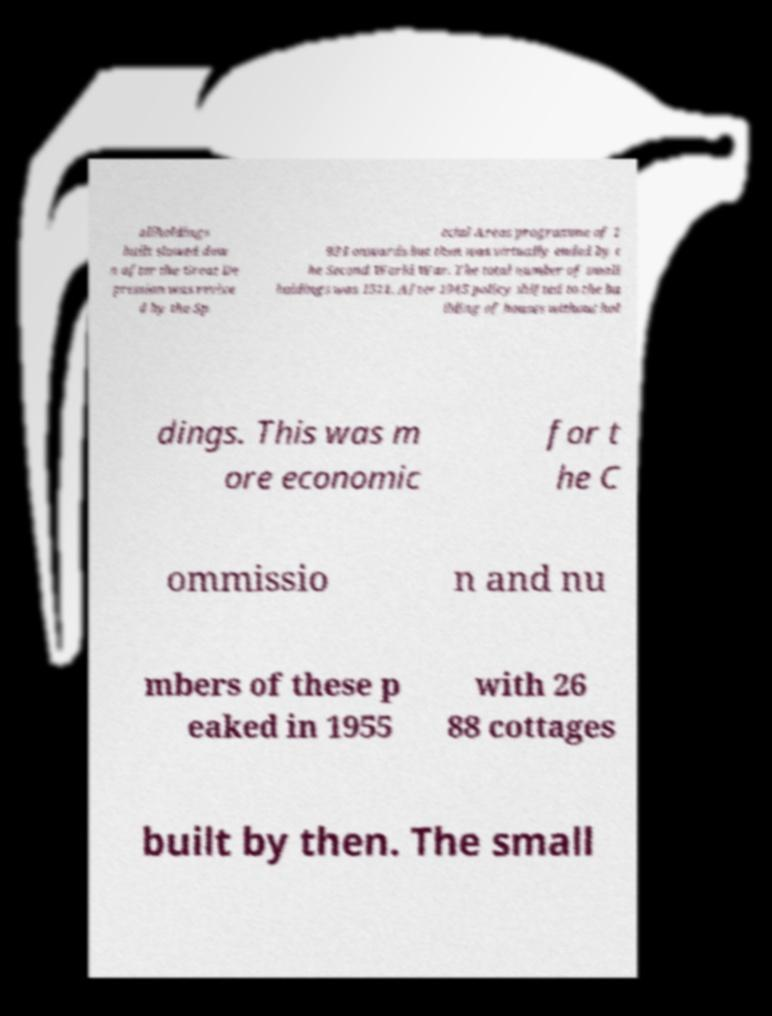Could you extract and type out the text from this image? allholdings built slowed dow n after the Great De pression was revive d by the Sp ecial Areas programme of 1 934 onwards but then was virtually ended by t he Second World War. The total number of small holdings was 1511. After 1945 policy shifted to the bu ilding of houses without hol dings. This was m ore economic for t he C ommissio n and nu mbers of these p eaked in 1955 with 26 88 cottages built by then. The small 